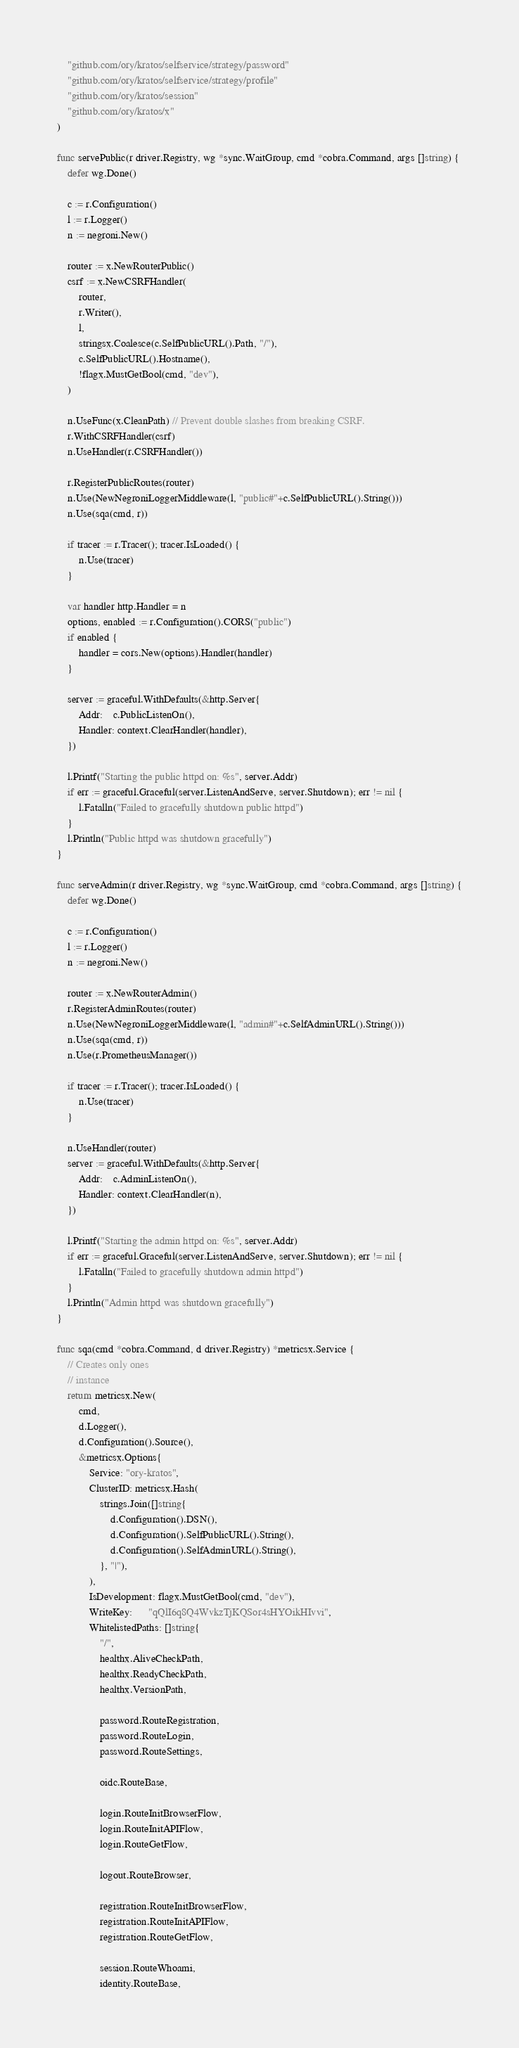Convert code to text. <code><loc_0><loc_0><loc_500><loc_500><_Go_>	"github.com/ory/kratos/selfservice/strategy/password"
	"github.com/ory/kratos/selfservice/strategy/profile"
	"github.com/ory/kratos/session"
	"github.com/ory/kratos/x"
)

func servePublic(r driver.Registry, wg *sync.WaitGroup, cmd *cobra.Command, args []string) {
	defer wg.Done()

	c := r.Configuration()
	l := r.Logger()
	n := negroni.New()

	router := x.NewRouterPublic()
	csrf := x.NewCSRFHandler(
		router,
		r.Writer(),
		l,
		stringsx.Coalesce(c.SelfPublicURL().Path, "/"),
		c.SelfPublicURL().Hostname(),
		!flagx.MustGetBool(cmd, "dev"),
	)

	n.UseFunc(x.CleanPath) // Prevent double slashes from breaking CSRF.
	r.WithCSRFHandler(csrf)
	n.UseHandler(r.CSRFHandler())

	r.RegisterPublicRoutes(router)
	n.Use(NewNegroniLoggerMiddleware(l, "public#"+c.SelfPublicURL().String()))
	n.Use(sqa(cmd, r))

	if tracer := r.Tracer(); tracer.IsLoaded() {
		n.Use(tracer)
	}

	var handler http.Handler = n
	options, enabled := r.Configuration().CORS("public")
	if enabled {
		handler = cors.New(options).Handler(handler)
	}

	server := graceful.WithDefaults(&http.Server{
		Addr:    c.PublicListenOn(),
		Handler: context.ClearHandler(handler),
	})

	l.Printf("Starting the public httpd on: %s", server.Addr)
	if err := graceful.Graceful(server.ListenAndServe, server.Shutdown); err != nil {
		l.Fatalln("Failed to gracefully shutdown public httpd")
	}
	l.Println("Public httpd was shutdown gracefully")
}

func serveAdmin(r driver.Registry, wg *sync.WaitGroup, cmd *cobra.Command, args []string) {
	defer wg.Done()

	c := r.Configuration()
	l := r.Logger()
	n := negroni.New()

	router := x.NewRouterAdmin()
	r.RegisterAdminRoutes(router)
	n.Use(NewNegroniLoggerMiddleware(l, "admin#"+c.SelfAdminURL().String()))
	n.Use(sqa(cmd, r))
	n.Use(r.PrometheusManager())

	if tracer := r.Tracer(); tracer.IsLoaded() {
		n.Use(tracer)
	}

	n.UseHandler(router)
	server := graceful.WithDefaults(&http.Server{
		Addr:    c.AdminListenOn(),
		Handler: context.ClearHandler(n),
	})

	l.Printf("Starting the admin httpd on: %s", server.Addr)
	if err := graceful.Graceful(server.ListenAndServe, server.Shutdown); err != nil {
		l.Fatalln("Failed to gracefully shutdown admin httpd")
	}
	l.Println("Admin httpd was shutdown gracefully")
}

func sqa(cmd *cobra.Command, d driver.Registry) *metricsx.Service {
	// Creates only ones
	// instance
	return metricsx.New(
		cmd,
		d.Logger(),
		d.Configuration().Source(),
		&metricsx.Options{
			Service: "ory-kratos",
			ClusterID: metricsx.Hash(
				strings.Join([]string{
					d.Configuration().DSN(),
					d.Configuration().SelfPublicURL().String(),
					d.Configuration().SelfAdminURL().String(),
				}, "|"),
			),
			IsDevelopment: flagx.MustGetBool(cmd, "dev"),
			WriteKey:      "qQlI6q8Q4WvkzTjKQSor4sHYOikHIvvi",
			WhitelistedPaths: []string{
				"/",
				healthx.AliveCheckPath,
				healthx.ReadyCheckPath,
				healthx.VersionPath,

				password.RouteRegistration,
				password.RouteLogin,
				password.RouteSettings,

				oidc.RouteBase,

				login.RouteInitBrowserFlow,
				login.RouteInitAPIFlow,
				login.RouteGetFlow,

				logout.RouteBrowser,

				registration.RouteInitBrowserFlow,
				registration.RouteInitAPIFlow,
				registration.RouteGetFlow,

				session.RouteWhoami,
				identity.RouteBase,
</code> 